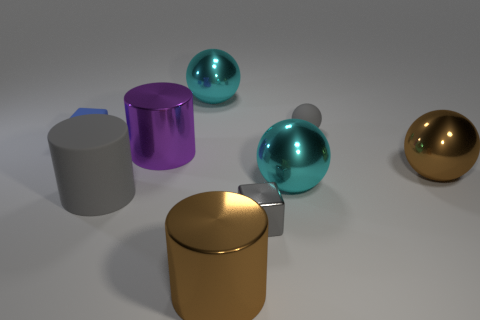There is a gray block that is made of the same material as the purple cylinder; what is its size?
Keep it short and to the point. Small. Is the number of big brown metal objects on the left side of the large brown ball greater than the number of gray rubber things that are in front of the rubber sphere?
Your answer should be very brief. No. What number of other things are there of the same material as the big purple cylinder
Provide a succinct answer. 5. Are the large cyan thing right of the gray metal thing and the big brown cylinder made of the same material?
Provide a short and direct response. Yes. The gray shiny object has what shape?
Your answer should be compact. Cube. Are there more big cyan shiny things that are in front of the small metallic cube than blue metal cubes?
Offer a very short reply. No. Is there anything else that is the same shape as the big gray matte thing?
Give a very brief answer. Yes. What is the color of the other object that is the same shape as the small gray shiny object?
Your answer should be very brief. Blue. There is a small matte thing right of the small blue matte object; what shape is it?
Offer a very short reply. Sphere. Are there any large gray cylinders left of the blue rubber cube?
Provide a succinct answer. No. 